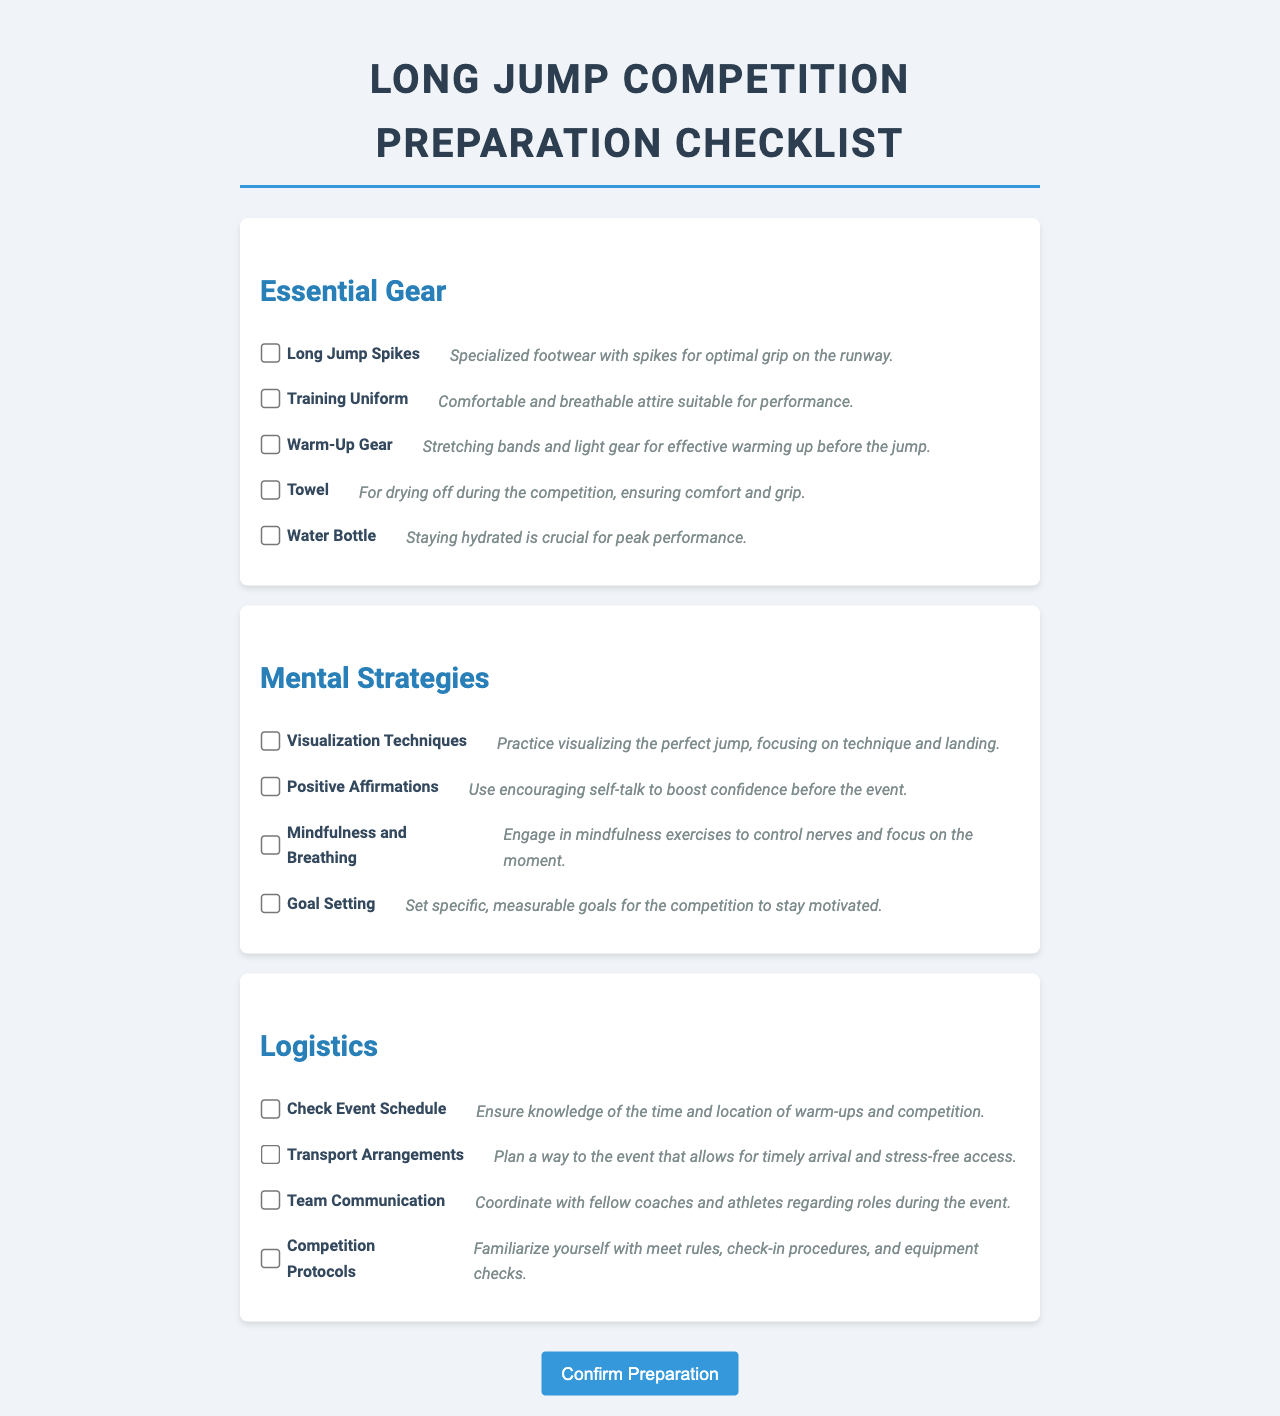what is the title of the document? The title is displayed prominently at the top of the page, indicating the purpose of the checklist.
Answer: Long Jump Competition Preparation Checklist how many sections are in the checklist? The document is organized into three distinct sections addressing different aspects of preparation.
Answer: 3 what is one item listed under Essential Gear? Essential Gear section contains various items that are crucial for performance during the event.
Answer: Long Jump Spikes which mental strategy involves encouraging self-talk? This strategy is aimed at building the athlete's confidence before the event, highlighted in the Mental Strategies section.
Answer: Positive Affirmations what should you do to control nerves according to the checklist? This is a mental strategy that focuses on maintaining composure and focus before performing.
Answer: Mindfulness and Breathing what type of arrangements does the Logistics section emphasize? This aspect is crucial for ensuring athletes arrive at the event on time, stressing the importance of planning ahead.
Answer: Transport Arrangements how can athletes stay hydrated according to the checklist? Staying properly hydrated is important for performance and is mentioned as a necessary item.
Answer: Water Bottle what is the purpose of goal setting in the checklist? Goal Setting is emphasized as a means to stay motivated during the competition based on the context provided.
Answer: To stay motivated what item is recommended for drying off during the competition? This item is listed under Essential Gear and is significant for maintaining grip and comfort.
Answer: Towel 